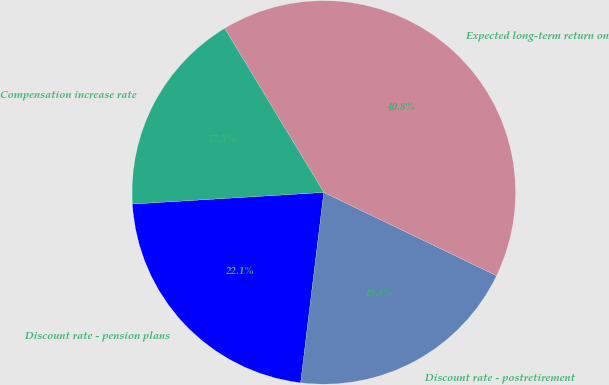Convert chart to OTSL. <chart><loc_0><loc_0><loc_500><loc_500><pie_chart><fcel>Discount rate - pension plans<fcel>Discount rate - postretirement<fcel>Expected long-term return on<fcel>Compensation increase rate<nl><fcel>22.11%<fcel>19.78%<fcel>40.8%<fcel>17.31%<nl></chart> 